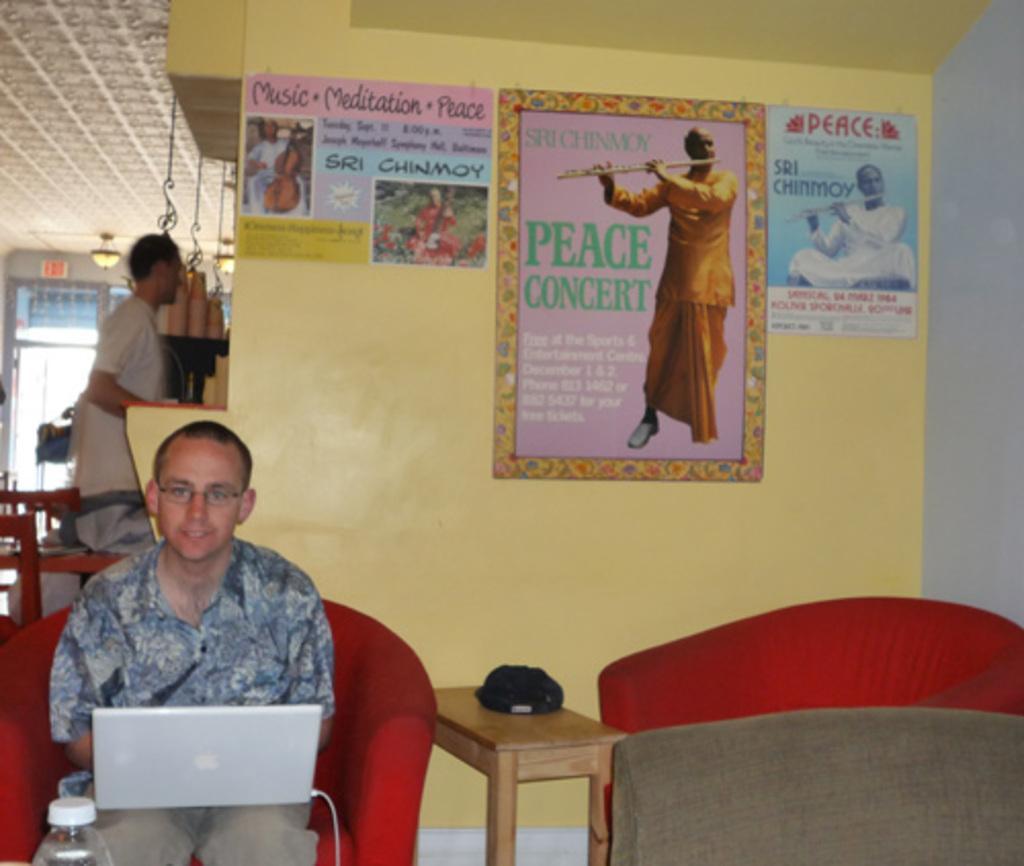Please provide a concise description of this image. In this picture we can see man sitting on chair and on him there is laptop in front of him there is bottle beside to him table and on table we can see some cloth and in the background we can see man standing, lamp, wall and three posters to that wall. 